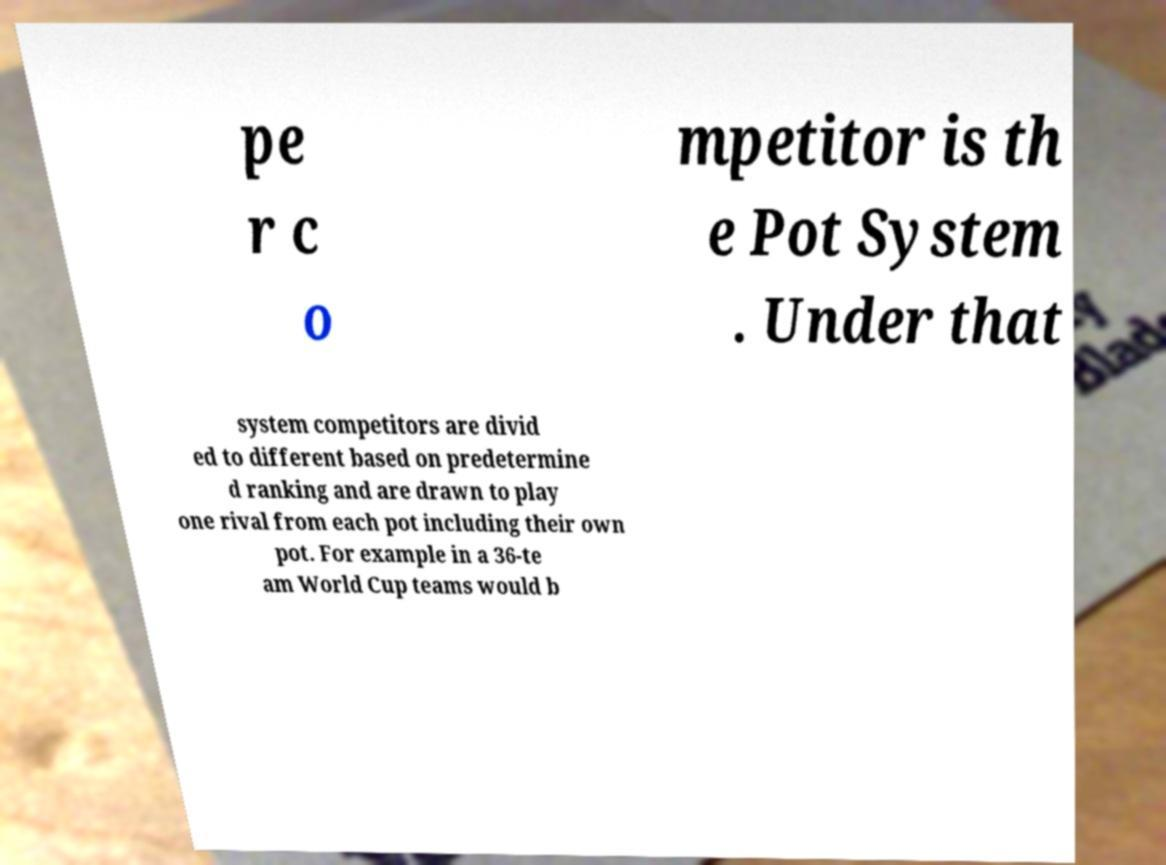There's text embedded in this image that I need extracted. Can you transcribe it verbatim? pe r c o mpetitor is th e Pot System . Under that system competitors are divid ed to different based on predetermine d ranking and are drawn to play one rival from each pot including their own pot. For example in a 36-te am World Cup teams would b 